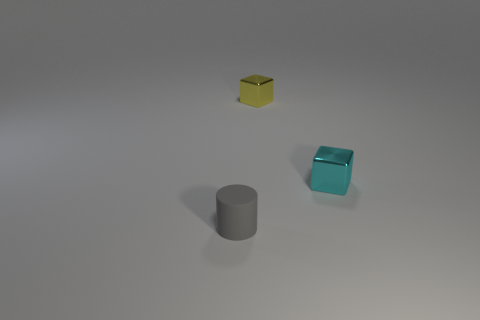Subtract 1 blocks. How many blocks are left? 1 Add 2 cyan metallic blocks. How many objects exist? 5 Subtract all blocks. How many objects are left? 1 Add 1 cyan cubes. How many cyan cubes are left? 2 Add 2 large green metal things. How many large green metal things exist? 2 Subtract 0 cyan spheres. How many objects are left? 3 Subtract all cyan metallic cubes. Subtract all tiny blocks. How many objects are left? 0 